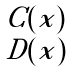<formula> <loc_0><loc_0><loc_500><loc_500>\begin{smallmatrix} C ( x ) \\ D ( x ) \end{smallmatrix}</formula> 